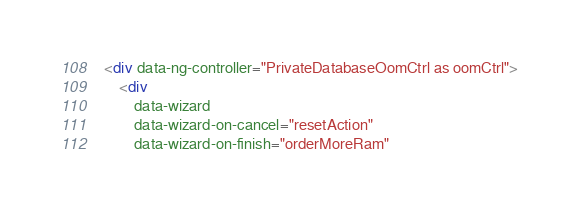<code> <loc_0><loc_0><loc_500><loc_500><_HTML_><div data-ng-controller="PrivateDatabaseOomCtrl as oomCtrl">
    <div
        data-wizard
        data-wizard-on-cancel="resetAction"
        data-wizard-on-finish="orderMoreRam"</code> 